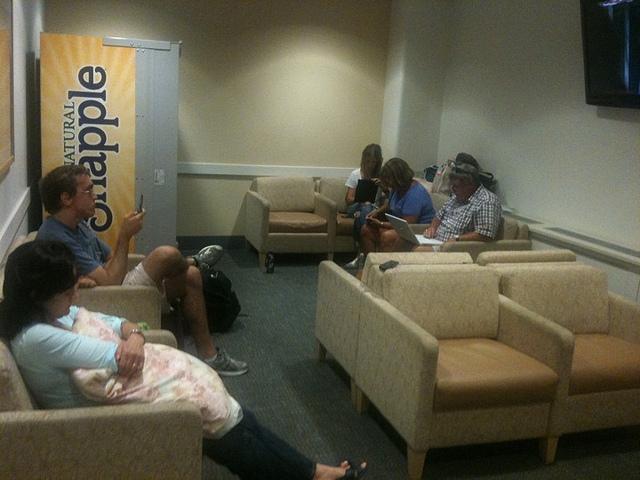What sort of beverages are most readily available here?
Choose the correct response and explain in the format: 'Answer: answer
Rationale: rationale.'
Options: Hot chocolate, icees, coffee, iced tea. Answer: iced tea.
Rationale: A snapple machine is in a waiting room. snapple makes tea. 